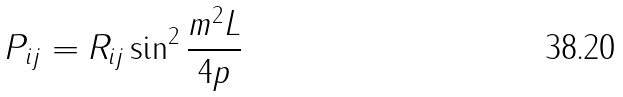Convert formula to latex. <formula><loc_0><loc_0><loc_500><loc_500>P _ { i j } = R _ { i j } \sin ^ { 2 } \frac { m ^ { 2 } L } { 4 p }</formula> 